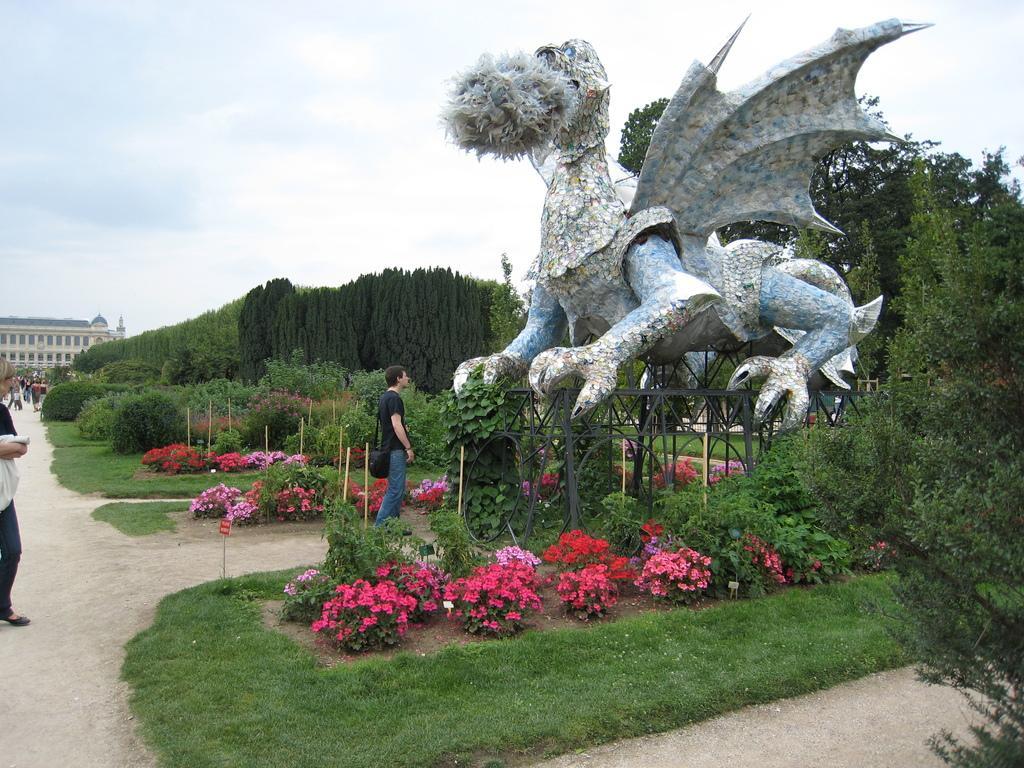Can you describe this image briefly? In this image we can see people, grass, plants, flowers, trees, building, and a statue. In the background there is sky with clouds. 